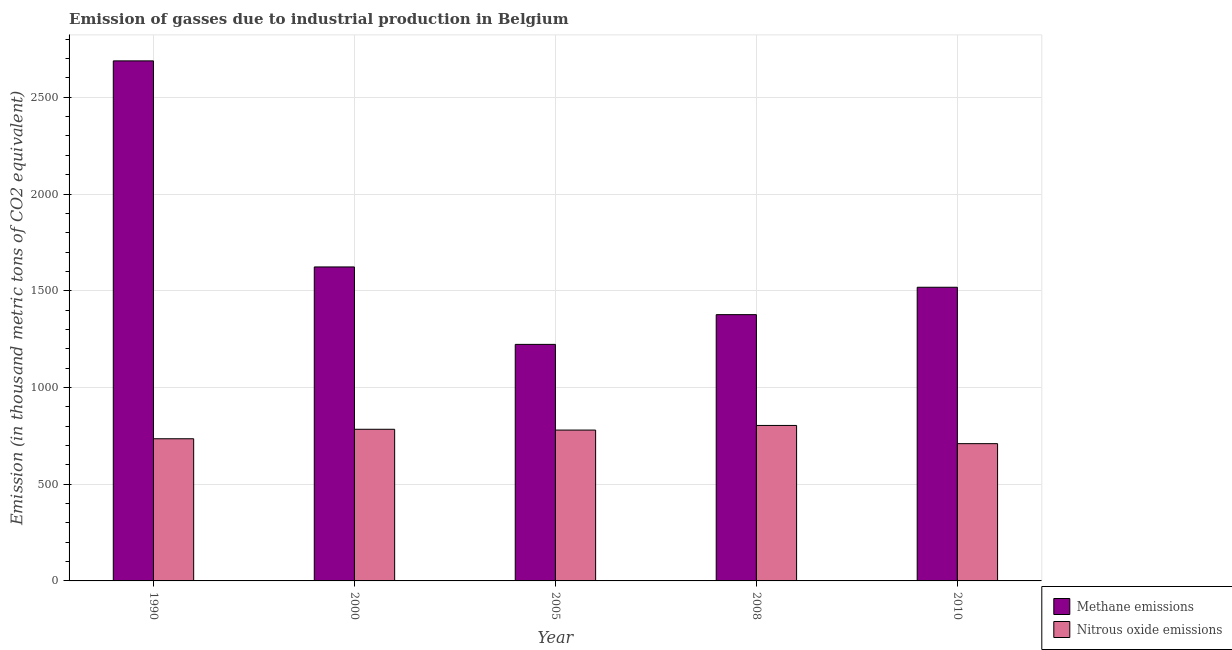How many groups of bars are there?
Your answer should be compact. 5. Are the number of bars per tick equal to the number of legend labels?
Keep it short and to the point. Yes. Are the number of bars on each tick of the X-axis equal?
Your answer should be compact. Yes. How many bars are there on the 3rd tick from the left?
Offer a terse response. 2. How many bars are there on the 5th tick from the right?
Provide a short and direct response. 2. What is the amount of nitrous oxide emissions in 2000?
Offer a terse response. 783.9. Across all years, what is the maximum amount of methane emissions?
Give a very brief answer. 2688.2. Across all years, what is the minimum amount of nitrous oxide emissions?
Provide a succinct answer. 709.6. In which year was the amount of methane emissions maximum?
Provide a short and direct response. 1990. In which year was the amount of methane emissions minimum?
Give a very brief answer. 2005. What is the total amount of nitrous oxide emissions in the graph?
Your answer should be very brief. 3811.9. What is the difference between the amount of nitrous oxide emissions in 2000 and that in 2005?
Your response must be concise. 4.1. What is the difference between the amount of methane emissions in 2008 and the amount of nitrous oxide emissions in 2010?
Make the answer very short. -141.6. What is the average amount of nitrous oxide emissions per year?
Keep it short and to the point. 762.38. In the year 2000, what is the difference between the amount of nitrous oxide emissions and amount of methane emissions?
Your response must be concise. 0. In how many years, is the amount of methane emissions greater than 2700 thousand metric tons?
Your response must be concise. 0. What is the ratio of the amount of methane emissions in 1990 to that in 2005?
Offer a very short reply. 2.2. Is the amount of nitrous oxide emissions in 2000 less than that in 2005?
Your answer should be very brief. No. What is the difference between the highest and the second highest amount of nitrous oxide emissions?
Offer a terse response. 19.8. What is the difference between the highest and the lowest amount of methane emissions?
Provide a short and direct response. 1465.5. In how many years, is the amount of nitrous oxide emissions greater than the average amount of nitrous oxide emissions taken over all years?
Ensure brevity in your answer.  3. What does the 2nd bar from the left in 2010 represents?
Your answer should be very brief. Nitrous oxide emissions. What does the 2nd bar from the right in 2010 represents?
Keep it short and to the point. Methane emissions. Are all the bars in the graph horizontal?
Provide a succinct answer. No. How many years are there in the graph?
Your answer should be compact. 5. Does the graph contain any zero values?
Provide a short and direct response. No. How many legend labels are there?
Offer a very short reply. 2. What is the title of the graph?
Give a very brief answer. Emission of gasses due to industrial production in Belgium. What is the label or title of the Y-axis?
Keep it short and to the point. Emission (in thousand metric tons of CO2 equivalent). What is the Emission (in thousand metric tons of CO2 equivalent) of Methane emissions in 1990?
Provide a short and direct response. 2688.2. What is the Emission (in thousand metric tons of CO2 equivalent) in Nitrous oxide emissions in 1990?
Ensure brevity in your answer.  734.9. What is the Emission (in thousand metric tons of CO2 equivalent) in Methane emissions in 2000?
Your answer should be very brief. 1623. What is the Emission (in thousand metric tons of CO2 equivalent) in Nitrous oxide emissions in 2000?
Your response must be concise. 783.9. What is the Emission (in thousand metric tons of CO2 equivalent) in Methane emissions in 2005?
Offer a very short reply. 1222.7. What is the Emission (in thousand metric tons of CO2 equivalent) of Nitrous oxide emissions in 2005?
Provide a short and direct response. 779.8. What is the Emission (in thousand metric tons of CO2 equivalent) in Methane emissions in 2008?
Make the answer very short. 1376.4. What is the Emission (in thousand metric tons of CO2 equivalent) in Nitrous oxide emissions in 2008?
Provide a short and direct response. 803.7. What is the Emission (in thousand metric tons of CO2 equivalent) in Methane emissions in 2010?
Provide a succinct answer. 1518. What is the Emission (in thousand metric tons of CO2 equivalent) of Nitrous oxide emissions in 2010?
Make the answer very short. 709.6. Across all years, what is the maximum Emission (in thousand metric tons of CO2 equivalent) in Methane emissions?
Offer a very short reply. 2688.2. Across all years, what is the maximum Emission (in thousand metric tons of CO2 equivalent) in Nitrous oxide emissions?
Your answer should be compact. 803.7. Across all years, what is the minimum Emission (in thousand metric tons of CO2 equivalent) in Methane emissions?
Provide a succinct answer. 1222.7. Across all years, what is the minimum Emission (in thousand metric tons of CO2 equivalent) in Nitrous oxide emissions?
Make the answer very short. 709.6. What is the total Emission (in thousand metric tons of CO2 equivalent) in Methane emissions in the graph?
Offer a terse response. 8428.3. What is the total Emission (in thousand metric tons of CO2 equivalent) of Nitrous oxide emissions in the graph?
Provide a succinct answer. 3811.9. What is the difference between the Emission (in thousand metric tons of CO2 equivalent) in Methane emissions in 1990 and that in 2000?
Your response must be concise. 1065.2. What is the difference between the Emission (in thousand metric tons of CO2 equivalent) in Nitrous oxide emissions in 1990 and that in 2000?
Make the answer very short. -49. What is the difference between the Emission (in thousand metric tons of CO2 equivalent) of Methane emissions in 1990 and that in 2005?
Give a very brief answer. 1465.5. What is the difference between the Emission (in thousand metric tons of CO2 equivalent) in Nitrous oxide emissions in 1990 and that in 2005?
Keep it short and to the point. -44.9. What is the difference between the Emission (in thousand metric tons of CO2 equivalent) in Methane emissions in 1990 and that in 2008?
Make the answer very short. 1311.8. What is the difference between the Emission (in thousand metric tons of CO2 equivalent) of Nitrous oxide emissions in 1990 and that in 2008?
Offer a very short reply. -68.8. What is the difference between the Emission (in thousand metric tons of CO2 equivalent) in Methane emissions in 1990 and that in 2010?
Your answer should be very brief. 1170.2. What is the difference between the Emission (in thousand metric tons of CO2 equivalent) of Nitrous oxide emissions in 1990 and that in 2010?
Provide a succinct answer. 25.3. What is the difference between the Emission (in thousand metric tons of CO2 equivalent) in Methane emissions in 2000 and that in 2005?
Keep it short and to the point. 400.3. What is the difference between the Emission (in thousand metric tons of CO2 equivalent) of Nitrous oxide emissions in 2000 and that in 2005?
Your answer should be compact. 4.1. What is the difference between the Emission (in thousand metric tons of CO2 equivalent) of Methane emissions in 2000 and that in 2008?
Your answer should be compact. 246.6. What is the difference between the Emission (in thousand metric tons of CO2 equivalent) in Nitrous oxide emissions in 2000 and that in 2008?
Provide a succinct answer. -19.8. What is the difference between the Emission (in thousand metric tons of CO2 equivalent) of Methane emissions in 2000 and that in 2010?
Offer a very short reply. 105. What is the difference between the Emission (in thousand metric tons of CO2 equivalent) in Nitrous oxide emissions in 2000 and that in 2010?
Your answer should be compact. 74.3. What is the difference between the Emission (in thousand metric tons of CO2 equivalent) of Methane emissions in 2005 and that in 2008?
Make the answer very short. -153.7. What is the difference between the Emission (in thousand metric tons of CO2 equivalent) of Nitrous oxide emissions in 2005 and that in 2008?
Offer a terse response. -23.9. What is the difference between the Emission (in thousand metric tons of CO2 equivalent) of Methane emissions in 2005 and that in 2010?
Offer a very short reply. -295.3. What is the difference between the Emission (in thousand metric tons of CO2 equivalent) of Nitrous oxide emissions in 2005 and that in 2010?
Make the answer very short. 70.2. What is the difference between the Emission (in thousand metric tons of CO2 equivalent) in Methane emissions in 2008 and that in 2010?
Your response must be concise. -141.6. What is the difference between the Emission (in thousand metric tons of CO2 equivalent) of Nitrous oxide emissions in 2008 and that in 2010?
Give a very brief answer. 94.1. What is the difference between the Emission (in thousand metric tons of CO2 equivalent) in Methane emissions in 1990 and the Emission (in thousand metric tons of CO2 equivalent) in Nitrous oxide emissions in 2000?
Make the answer very short. 1904.3. What is the difference between the Emission (in thousand metric tons of CO2 equivalent) of Methane emissions in 1990 and the Emission (in thousand metric tons of CO2 equivalent) of Nitrous oxide emissions in 2005?
Your answer should be very brief. 1908.4. What is the difference between the Emission (in thousand metric tons of CO2 equivalent) in Methane emissions in 1990 and the Emission (in thousand metric tons of CO2 equivalent) in Nitrous oxide emissions in 2008?
Offer a very short reply. 1884.5. What is the difference between the Emission (in thousand metric tons of CO2 equivalent) in Methane emissions in 1990 and the Emission (in thousand metric tons of CO2 equivalent) in Nitrous oxide emissions in 2010?
Your answer should be very brief. 1978.6. What is the difference between the Emission (in thousand metric tons of CO2 equivalent) of Methane emissions in 2000 and the Emission (in thousand metric tons of CO2 equivalent) of Nitrous oxide emissions in 2005?
Offer a very short reply. 843.2. What is the difference between the Emission (in thousand metric tons of CO2 equivalent) of Methane emissions in 2000 and the Emission (in thousand metric tons of CO2 equivalent) of Nitrous oxide emissions in 2008?
Your answer should be compact. 819.3. What is the difference between the Emission (in thousand metric tons of CO2 equivalent) in Methane emissions in 2000 and the Emission (in thousand metric tons of CO2 equivalent) in Nitrous oxide emissions in 2010?
Offer a very short reply. 913.4. What is the difference between the Emission (in thousand metric tons of CO2 equivalent) of Methane emissions in 2005 and the Emission (in thousand metric tons of CO2 equivalent) of Nitrous oxide emissions in 2008?
Offer a very short reply. 419. What is the difference between the Emission (in thousand metric tons of CO2 equivalent) of Methane emissions in 2005 and the Emission (in thousand metric tons of CO2 equivalent) of Nitrous oxide emissions in 2010?
Provide a short and direct response. 513.1. What is the difference between the Emission (in thousand metric tons of CO2 equivalent) of Methane emissions in 2008 and the Emission (in thousand metric tons of CO2 equivalent) of Nitrous oxide emissions in 2010?
Make the answer very short. 666.8. What is the average Emission (in thousand metric tons of CO2 equivalent) of Methane emissions per year?
Make the answer very short. 1685.66. What is the average Emission (in thousand metric tons of CO2 equivalent) in Nitrous oxide emissions per year?
Give a very brief answer. 762.38. In the year 1990, what is the difference between the Emission (in thousand metric tons of CO2 equivalent) of Methane emissions and Emission (in thousand metric tons of CO2 equivalent) of Nitrous oxide emissions?
Offer a terse response. 1953.3. In the year 2000, what is the difference between the Emission (in thousand metric tons of CO2 equivalent) in Methane emissions and Emission (in thousand metric tons of CO2 equivalent) in Nitrous oxide emissions?
Your answer should be compact. 839.1. In the year 2005, what is the difference between the Emission (in thousand metric tons of CO2 equivalent) of Methane emissions and Emission (in thousand metric tons of CO2 equivalent) of Nitrous oxide emissions?
Provide a succinct answer. 442.9. In the year 2008, what is the difference between the Emission (in thousand metric tons of CO2 equivalent) of Methane emissions and Emission (in thousand metric tons of CO2 equivalent) of Nitrous oxide emissions?
Your answer should be compact. 572.7. In the year 2010, what is the difference between the Emission (in thousand metric tons of CO2 equivalent) of Methane emissions and Emission (in thousand metric tons of CO2 equivalent) of Nitrous oxide emissions?
Your answer should be compact. 808.4. What is the ratio of the Emission (in thousand metric tons of CO2 equivalent) in Methane emissions in 1990 to that in 2000?
Keep it short and to the point. 1.66. What is the ratio of the Emission (in thousand metric tons of CO2 equivalent) in Methane emissions in 1990 to that in 2005?
Provide a short and direct response. 2.2. What is the ratio of the Emission (in thousand metric tons of CO2 equivalent) in Nitrous oxide emissions in 1990 to that in 2005?
Make the answer very short. 0.94. What is the ratio of the Emission (in thousand metric tons of CO2 equivalent) in Methane emissions in 1990 to that in 2008?
Offer a very short reply. 1.95. What is the ratio of the Emission (in thousand metric tons of CO2 equivalent) in Nitrous oxide emissions in 1990 to that in 2008?
Offer a terse response. 0.91. What is the ratio of the Emission (in thousand metric tons of CO2 equivalent) in Methane emissions in 1990 to that in 2010?
Offer a very short reply. 1.77. What is the ratio of the Emission (in thousand metric tons of CO2 equivalent) in Nitrous oxide emissions in 1990 to that in 2010?
Your answer should be compact. 1.04. What is the ratio of the Emission (in thousand metric tons of CO2 equivalent) of Methane emissions in 2000 to that in 2005?
Give a very brief answer. 1.33. What is the ratio of the Emission (in thousand metric tons of CO2 equivalent) in Methane emissions in 2000 to that in 2008?
Your answer should be very brief. 1.18. What is the ratio of the Emission (in thousand metric tons of CO2 equivalent) in Nitrous oxide emissions in 2000 to that in 2008?
Your answer should be compact. 0.98. What is the ratio of the Emission (in thousand metric tons of CO2 equivalent) of Methane emissions in 2000 to that in 2010?
Your answer should be compact. 1.07. What is the ratio of the Emission (in thousand metric tons of CO2 equivalent) of Nitrous oxide emissions in 2000 to that in 2010?
Give a very brief answer. 1.1. What is the ratio of the Emission (in thousand metric tons of CO2 equivalent) of Methane emissions in 2005 to that in 2008?
Offer a terse response. 0.89. What is the ratio of the Emission (in thousand metric tons of CO2 equivalent) of Nitrous oxide emissions in 2005 to that in 2008?
Make the answer very short. 0.97. What is the ratio of the Emission (in thousand metric tons of CO2 equivalent) in Methane emissions in 2005 to that in 2010?
Your response must be concise. 0.81. What is the ratio of the Emission (in thousand metric tons of CO2 equivalent) in Nitrous oxide emissions in 2005 to that in 2010?
Provide a short and direct response. 1.1. What is the ratio of the Emission (in thousand metric tons of CO2 equivalent) of Methane emissions in 2008 to that in 2010?
Your answer should be compact. 0.91. What is the ratio of the Emission (in thousand metric tons of CO2 equivalent) of Nitrous oxide emissions in 2008 to that in 2010?
Your response must be concise. 1.13. What is the difference between the highest and the second highest Emission (in thousand metric tons of CO2 equivalent) of Methane emissions?
Keep it short and to the point. 1065.2. What is the difference between the highest and the second highest Emission (in thousand metric tons of CO2 equivalent) of Nitrous oxide emissions?
Ensure brevity in your answer.  19.8. What is the difference between the highest and the lowest Emission (in thousand metric tons of CO2 equivalent) of Methane emissions?
Make the answer very short. 1465.5. What is the difference between the highest and the lowest Emission (in thousand metric tons of CO2 equivalent) of Nitrous oxide emissions?
Offer a very short reply. 94.1. 